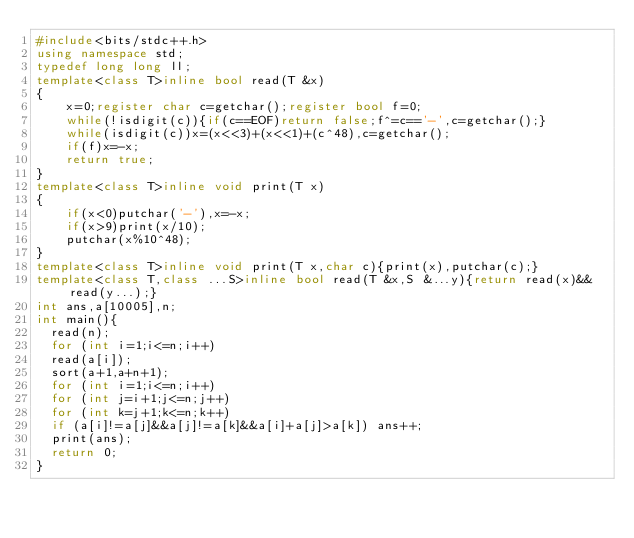Convert code to text. <code><loc_0><loc_0><loc_500><loc_500><_C++_>#include<bits/stdc++.h>
using namespace std;
typedef long long ll;
template<class T>inline bool read(T &x)
{
    x=0;register char c=getchar();register bool f=0;
    while(!isdigit(c)){if(c==EOF)return false;f^=c=='-',c=getchar();}
    while(isdigit(c))x=(x<<3)+(x<<1)+(c^48),c=getchar();
    if(f)x=-x;
    return true;
}
template<class T>inline void print(T x)
{
    if(x<0)putchar('-'),x=-x;
    if(x>9)print(x/10);
    putchar(x%10^48);
}
template<class T>inline void print(T x,char c){print(x),putchar(c);}
template<class T,class ...S>inline bool read(T &x,S &...y){return read(x)&&read(y...);}
int ans,a[10005],n;
int main(){
	read(n);
	for (int i=1;i<=n;i++)
	read(a[i]);
	sort(a+1,a+n+1);
	for (int i=1;i<=n;i++)
	for (int j=i+1;j<=n;j++)
	for (int k=j+1;k<=n;k++)
	if (a[i]!=a[j]&&a[j]!=a[k]&&a[i]+a[j]>a[k]) ans++;
	print(ans);
	return 0;
}</code> 